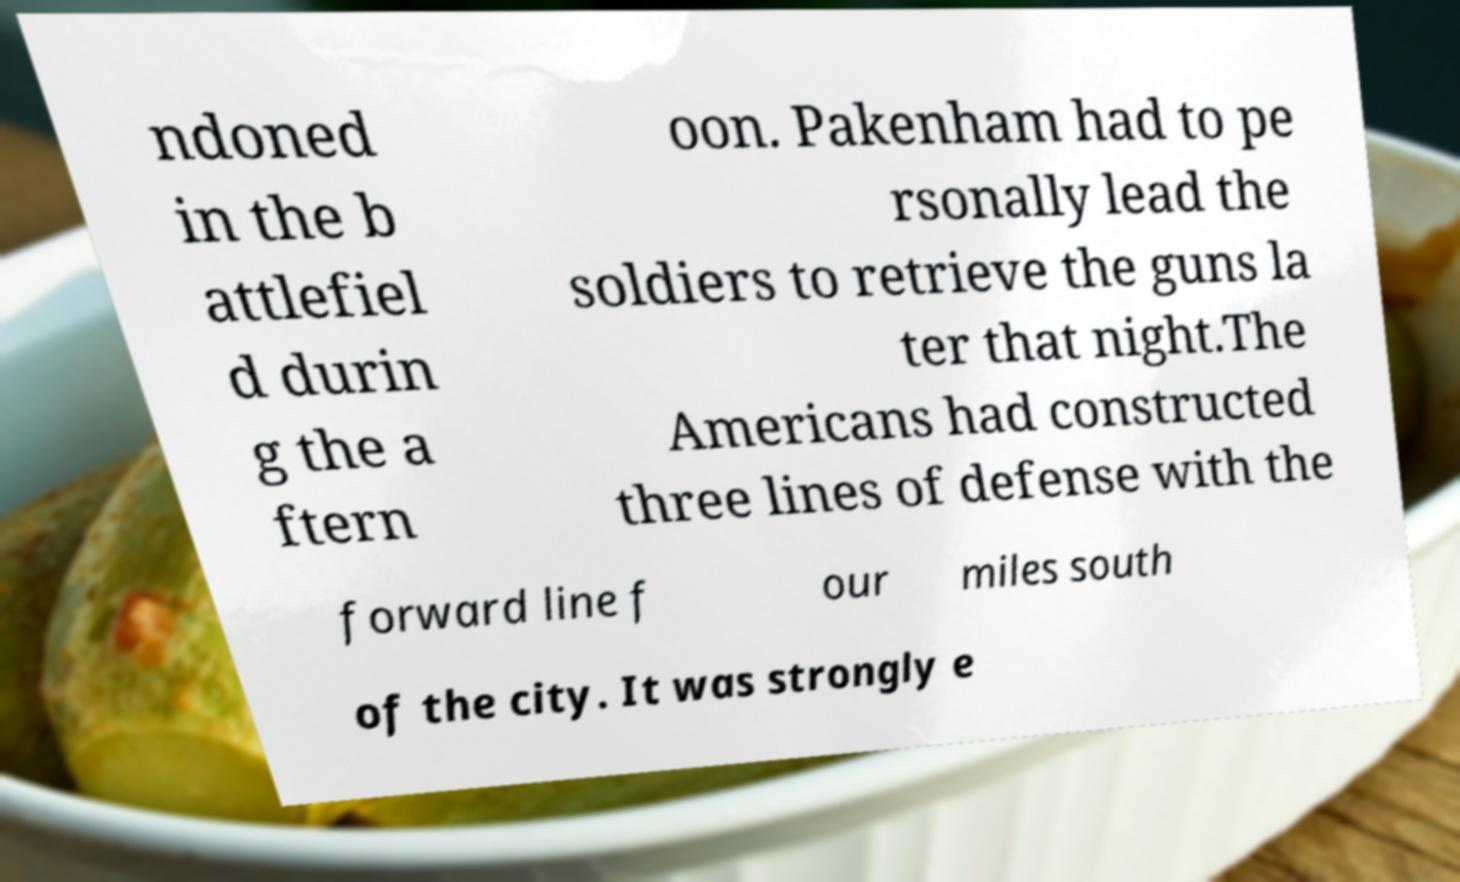Could you extract and type out the text from this image? ndoned in the b attlefiel d durin g the a ftern oon. Pakenham had to pe rsonally lead the soldiers to retrieve the guns la ter that night.The Americans had constructed three lines of defense with the forward line f our miles south of the city. It was strongly e 